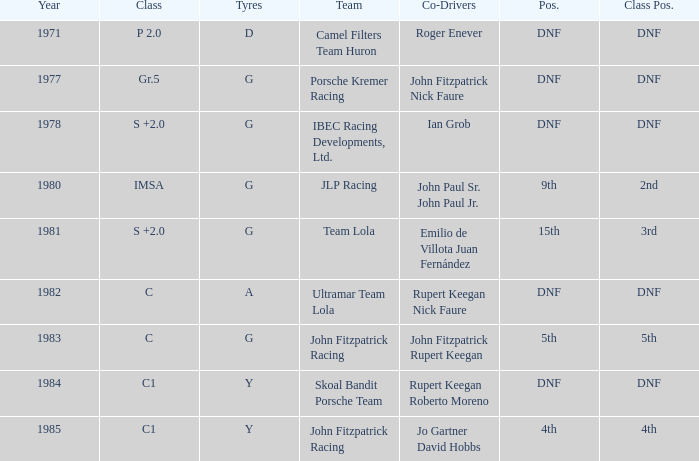When was the first year that included a co-driver of roger enever? 1971.0. 